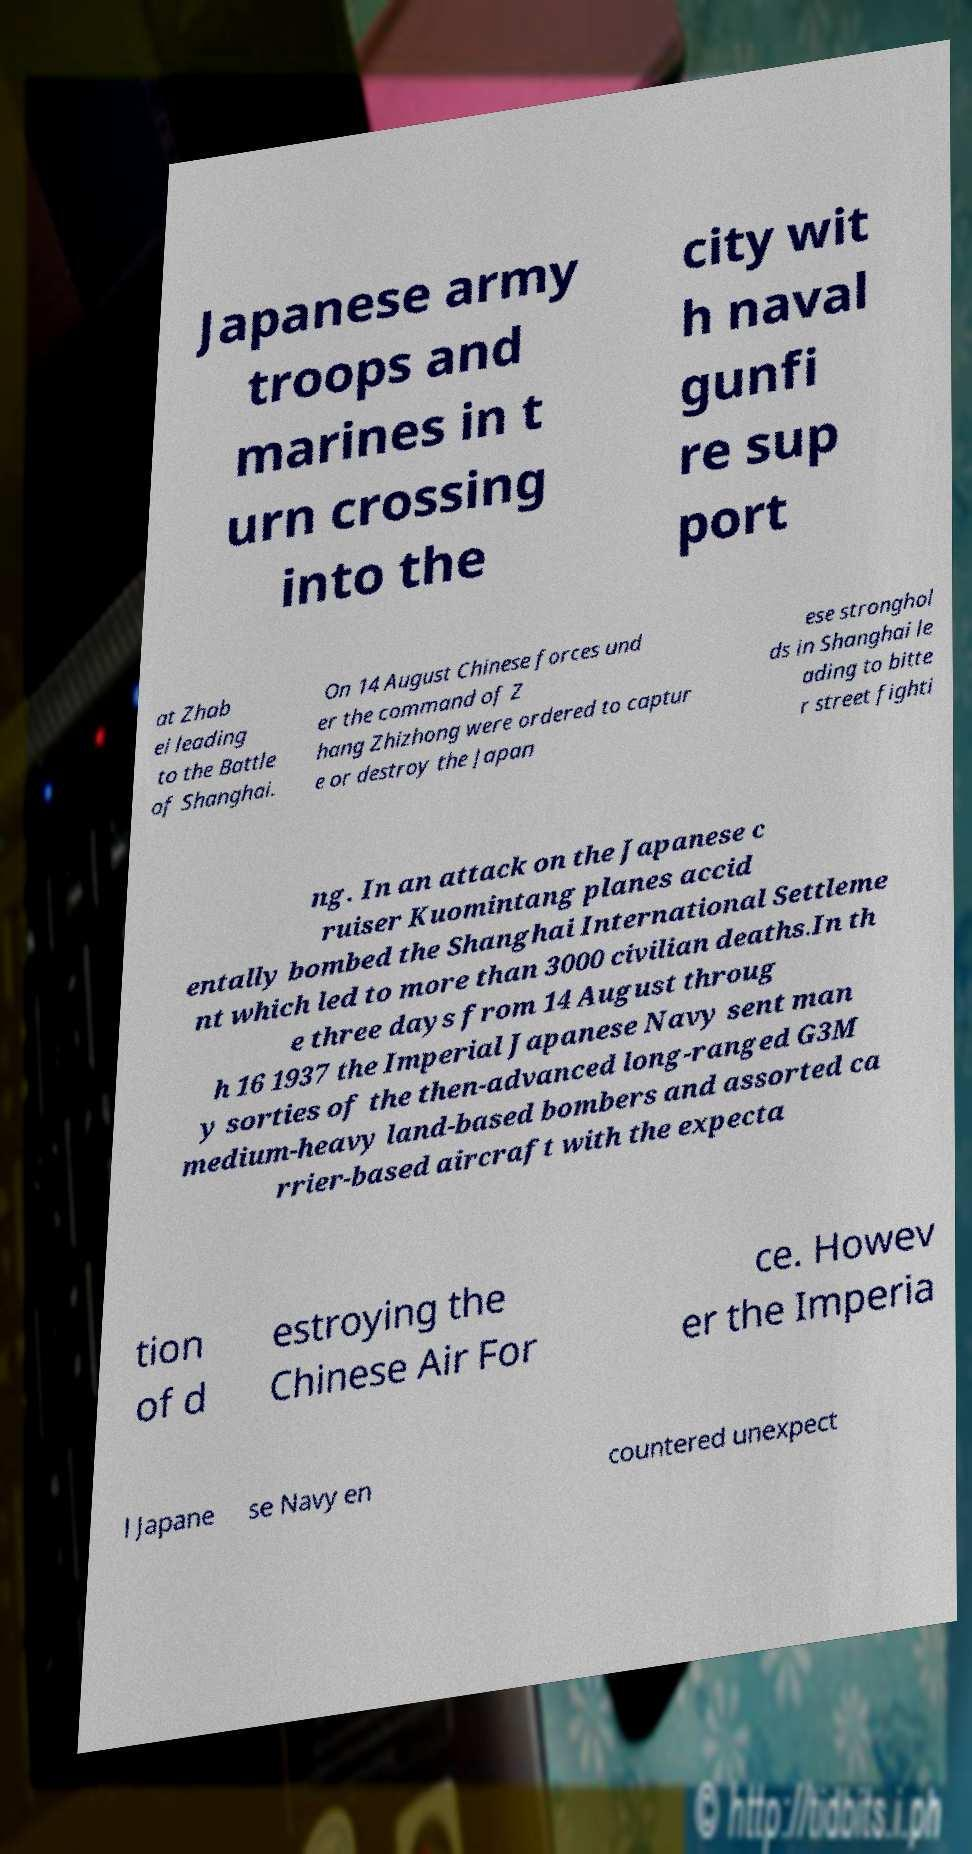I need the written content from this picture converted into text. Can you do that? Japanese army troops and marines in t urn crossing into the city wit h naval gunfi re sup port at Zhab ei leading to the Battle of Shanghai. On 14 August Chinese forces und er the command of Z hang Zhizhong were ordered to captur e or destroy the Japan ese stronghol ds in Shanghai le ading to bitte r street fighti ng. In an attack on the Japanese c ruiser Kuomintang planes accid entally bombed the Shanghai International Settleme nt which led to more than 3000 civilian deaths.In th e three days from 14 August throug h 16 1937 the Imperial Japanese Navy sent man y sorties of the then-advanced long-ranged G3M medium-heavy land-based bombers and assorted ca rrier-based aircraft with the expecta tion of d estroying the Chinese Air For ce. Howev er the Imperia l Japane se Navy en countered unexpect 